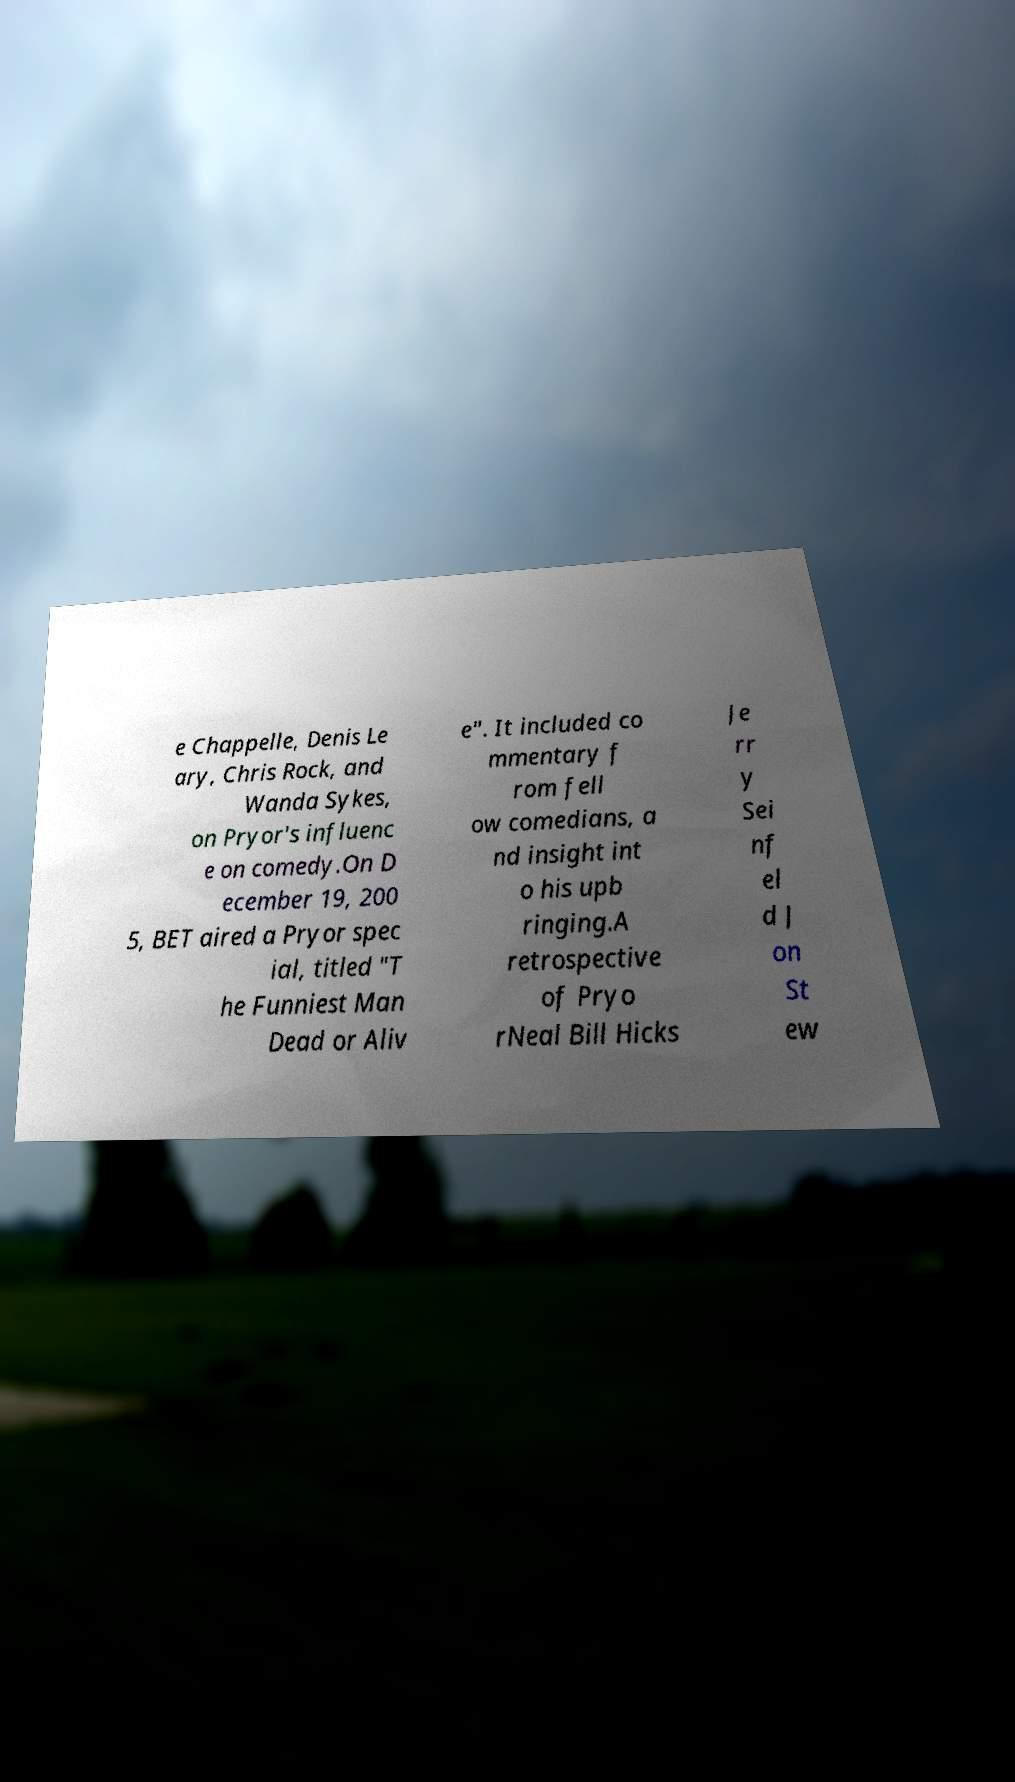Please read and relay the text visible in this image. What does it say? e Chappelle, Denis Le ary, Chris Rock, and Wanda Sykes, on Pryor's influenc e on comedy.On D ecember 19, 200 5, BET aired a Pryor spec ial, titled "T he Funniest Man Dead or Aliv e". It included co mmentary f rom fell ow comedians, a nd insight int o his upb ringing.A retrospective of Pryo rNeal Bill Hicks Je rr y Sei nf el d J on St ew 